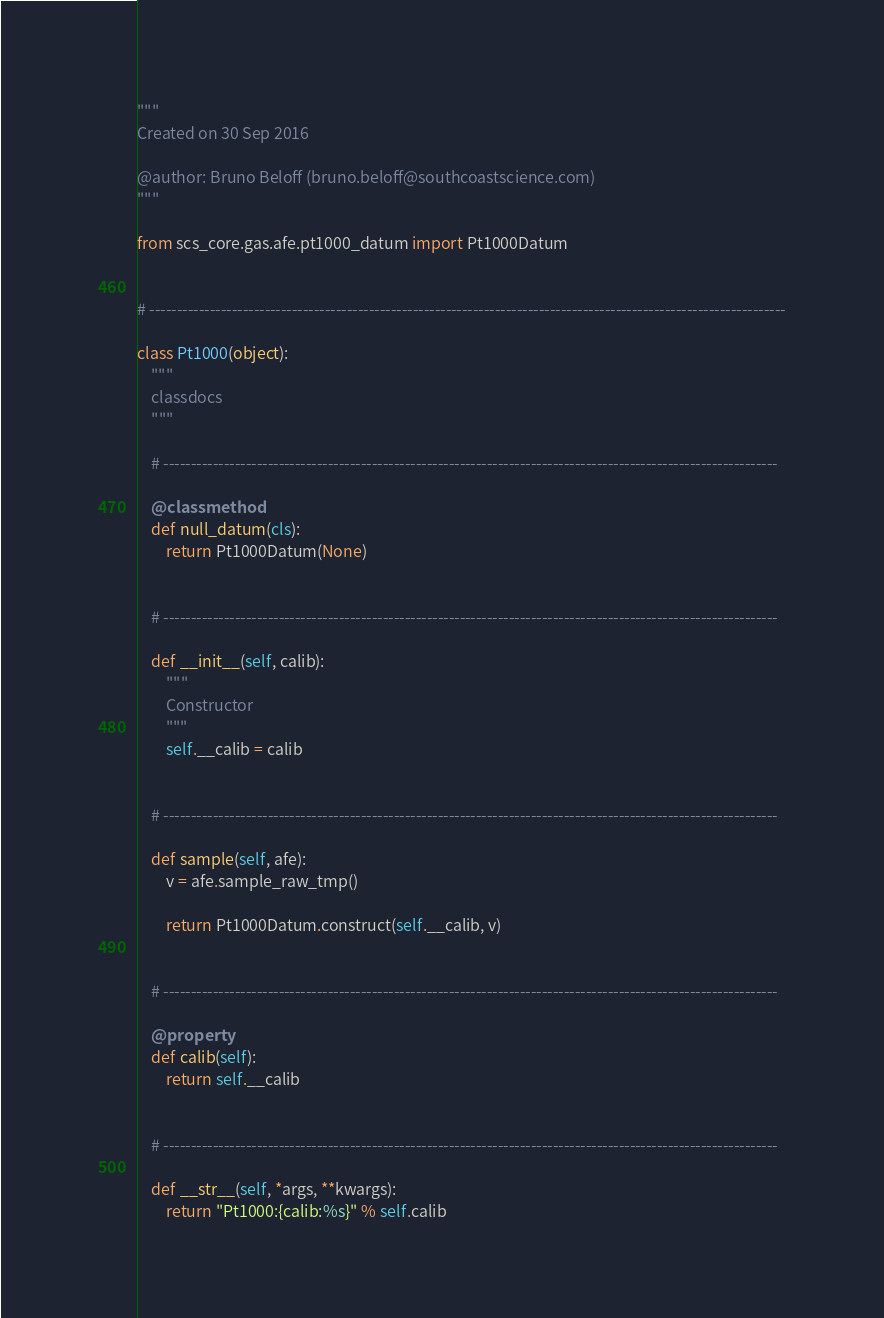<code> <loc_0><loc_0><loc_500><loc_500><_Python_>"""
Created on 30 Sep 2016

@author: Bruno Beloff (bruno.beloff@southcoastscience.com)
"""

from scs_core.gas.afe.pt1000_datum import Pt1000Datum


# --------------------------------------------------------------------------------------------------------------------

class Pt1000(object):
    """
    classdocs
    """

    # ----------------------------------------------------------------------------------------------------------------

    @classmethod
    def null_datum(cls):
        return Pt1000Datum(None)


    # ----------------------------------------------------------------------------------------------------------------

    def __init__(self, calib):
        """
        Constructor
        """
        self.__calib = calib


    # ----------------------------------------------------------------------------------------------------------------

    def sample(self, afe):
        v = afe.sample_raw_tmp()

        return Pt1000Datum.construct(self.__calib, v)


    # ----------------------------------------------------------------------------------------------------------------

    @property
    def calib(self):
        return self.__calib


    # ----------------------------------------------------------------------------------------------------------------

    def __str__(self, *args, **kwargs):
        return "Pt1000:{calib:%s}" % self.calib
</code> 